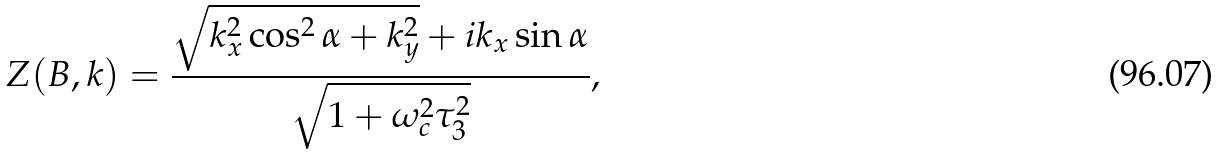<formula> <loc_0><loc_0><loc_500><loc_500>Z ( { B } , { k } ) = \frac { \sqrt { k _ { x } ^ { 2 } \cos ^ { 2 } \alpha + k _ { y } ^ { 2 } } + i k _ { x } \sin \alpha } { \sqrt { 1 + \omega _ { c } ^ { 2 } \tau _ { 3 } ^ { 2 } } } ,</formula> 